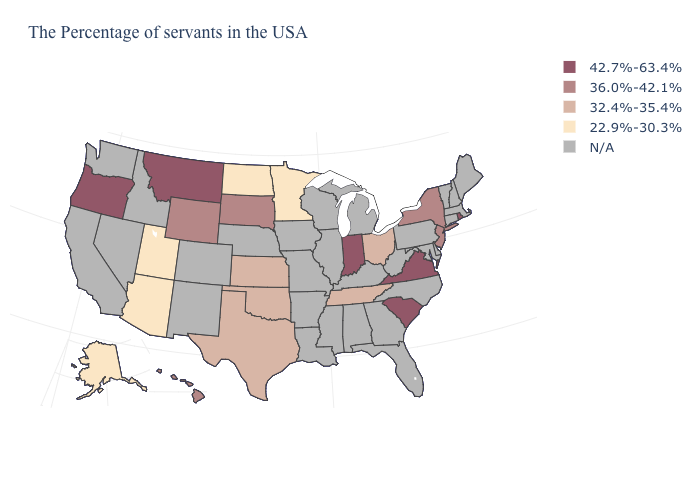Which states have the highest value in the USA?
Quick response, please. Rhode Island, Virginia, South Carolina, Indiana, Montana, Oregon. How many symbols are there in the legend?
Answer briefly. 5. What is the value of New York?
Short answer required. 36.0%-42.1%. Name the states that have a value in the range 42.7%-63.4%?
Keep it brief. Rhode Island, Virginia, South Carolina, Indiana, Montana, Oregon. What is the lowest value in the USA?
Answer briefly. 22.9%-30.3%. What is the value of Idaho?
Give a very brief answer. N/A. Name the states that have a value in the range 42.7%-63.4%?
Quick response, please. Rhode Island, Virginia, South Carolina, Indiana, Montana, Oregon. What is the value of Ohio?
Give a very brief answer. 32.4%-35.4%. Name the states that have a value in the range 32.4%-35.4%?
Write a very short answer. Ohio, Tennessee, Kansas, Oklahoma, Texas. Name the states that have a value in the range 32.4%-35.4%?
Concise answer only. Ohio, Tennessee, Kansas, Oklahoma, Texas. Which states have the lowest value in the West?
Answer briefly. Utah, Arizona, Alaska. How many symbols are there in the legend?
Quick response, please. 5. Name the states that have a value in the range 22.9%-30.3%?
Keep it brief. Minnesota, North Dakota, Utah, Arizona, Alaska. 